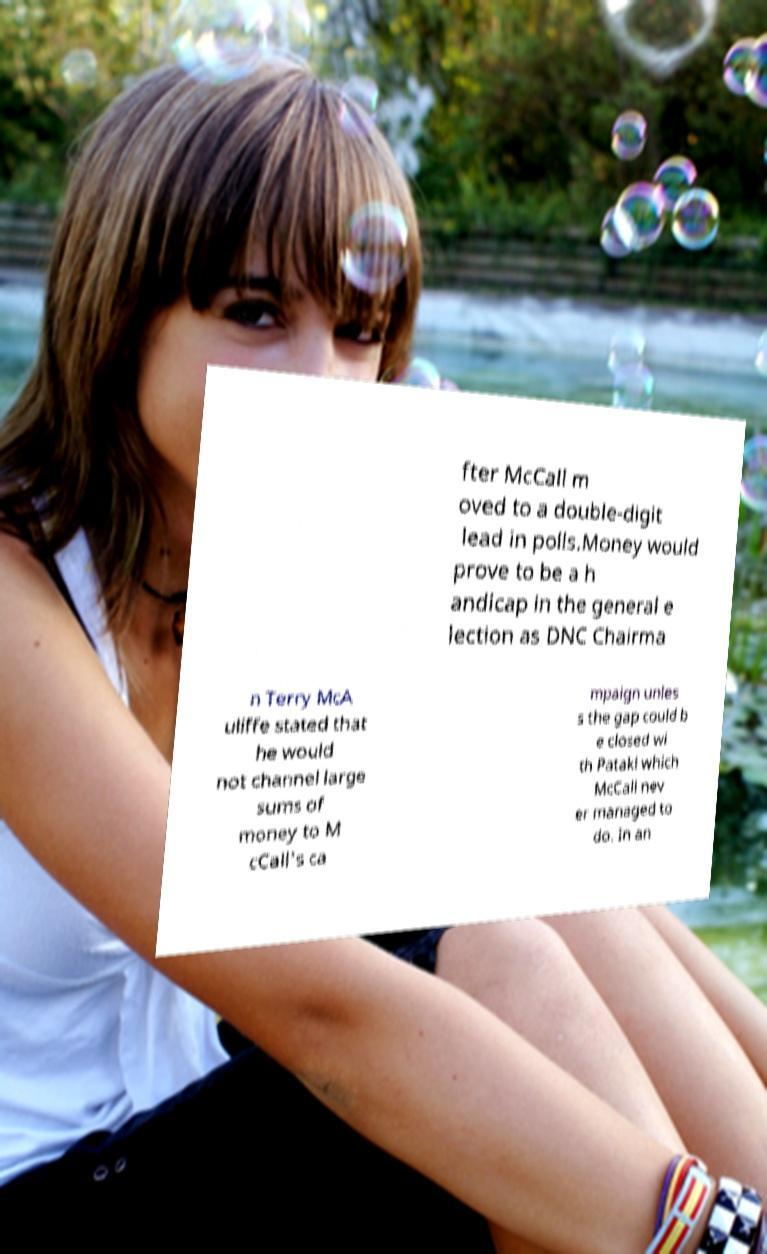For documentation purposes, I need the text within this image transcribed. Could you provide that? fter McCall m oved to a double-digit lead in polls.Money would prove to be a h andicap in the general e lection as DNC Chairma n Terry McA uliffe stated that he would not channel large sums of money to M cCall's ca mpaign unles s the gap could b e closed wi th Pataki which McCall nev er managed to do. In an 